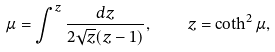Convert formula to latex. <formula><loc_0><loc_0><loc_500><loc_500>\mu = \int ^ { z } \frac { d z } { 2 \sqrt { z } ( z - 1 ) } , \quad z = \coth ^ { 2 } \mu ,</formula> 